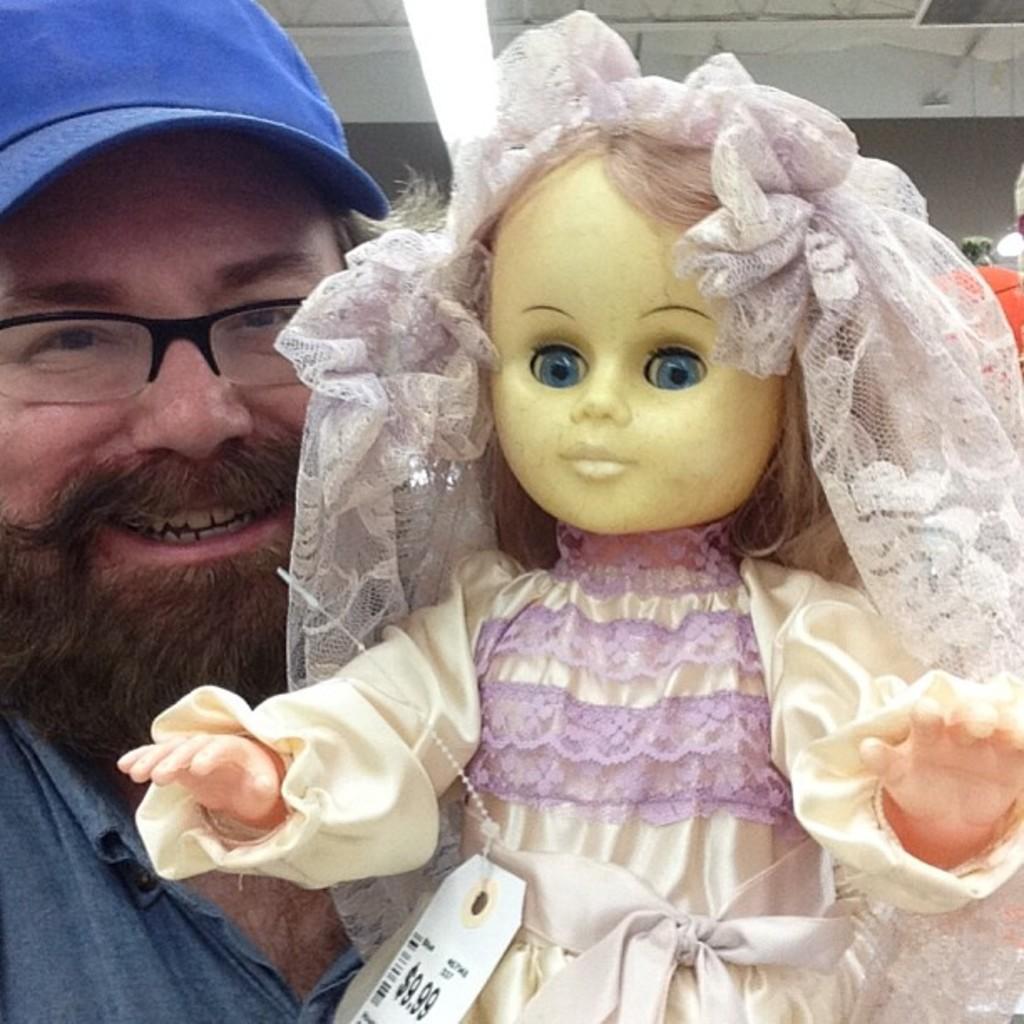How would you summarize this image in a sentence or two? In this image I can see the person holding the toy. The person is wearing the blue color dress and also the blue color cap. The toy is in cream and purple color and there is a price tag to the toy. In the back I can see the building. 